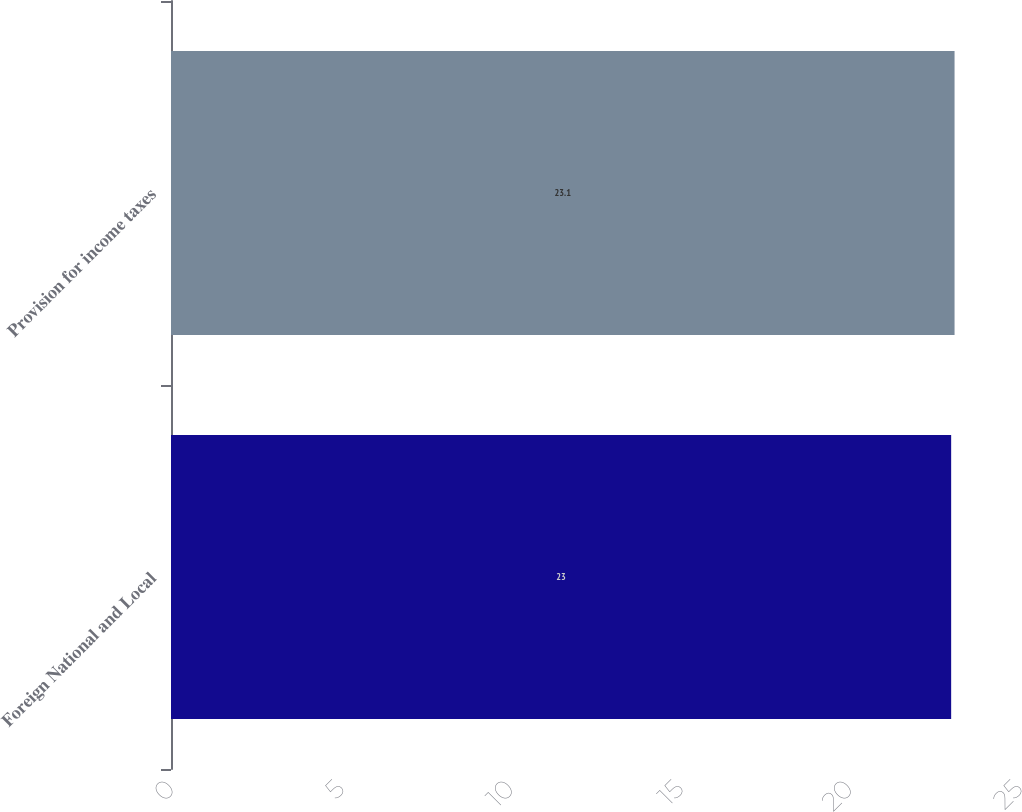<chart> <loc_0><loc_0><loc_500><loc_500><bar_chart><fcel>Foreign National and Local<fcel>Provision for income taxes<nl><fcel>23<fcel>23.1<nl></chart> 